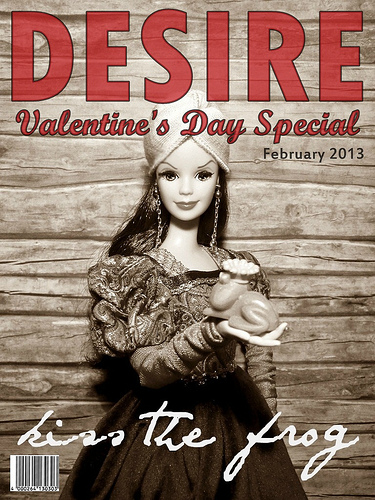<image>
Is there a frog to the right of the doll? Yes. From this viewpoint, the frog is positioned to the right side relative to the doll. 